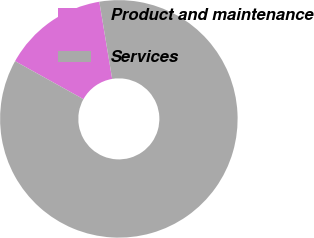Convert chart to OTSL. <chart><loc_0><loc_0><loc_500><loc_500><pie_chart><fcel>Product and maintenance<fcel>Services<nl><fcel>14.29%<fcel>85.71%<nl></chart> 